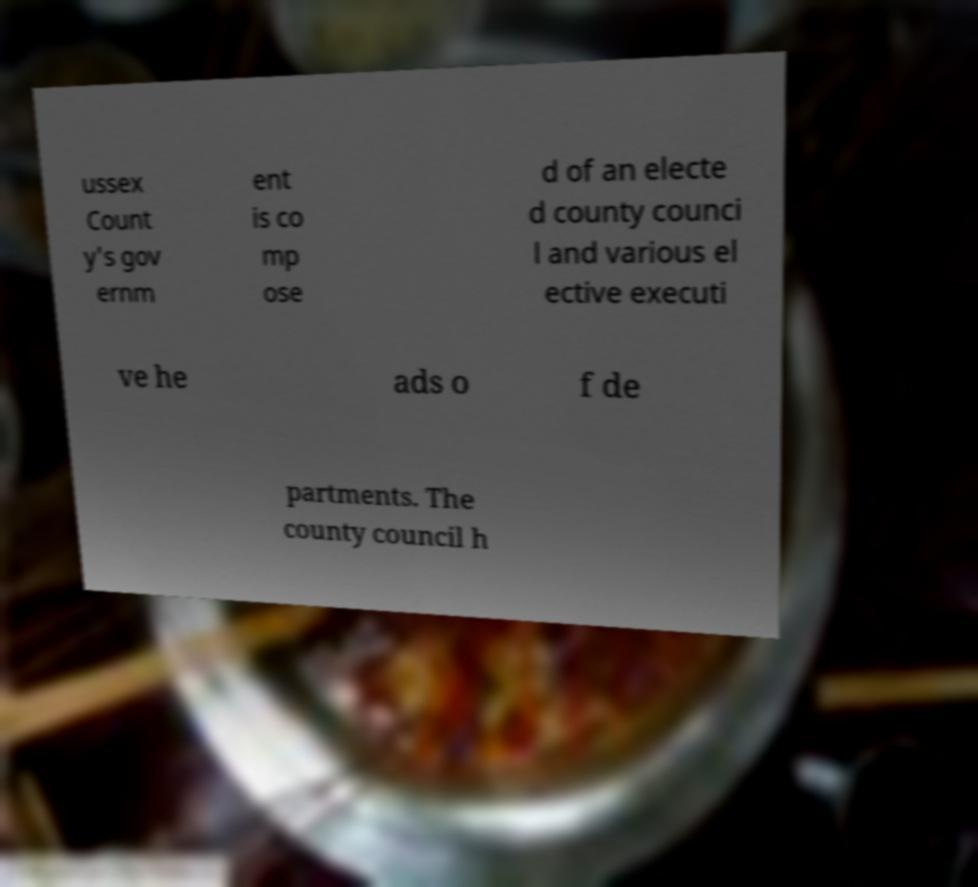Could you assist in decoding the text presented in this image and type it out clearly? ussex Count y's gov ernm ent is co mp ose d of an electe d county counci l and various el ective executi ve he ads o f de partments. The county council h 